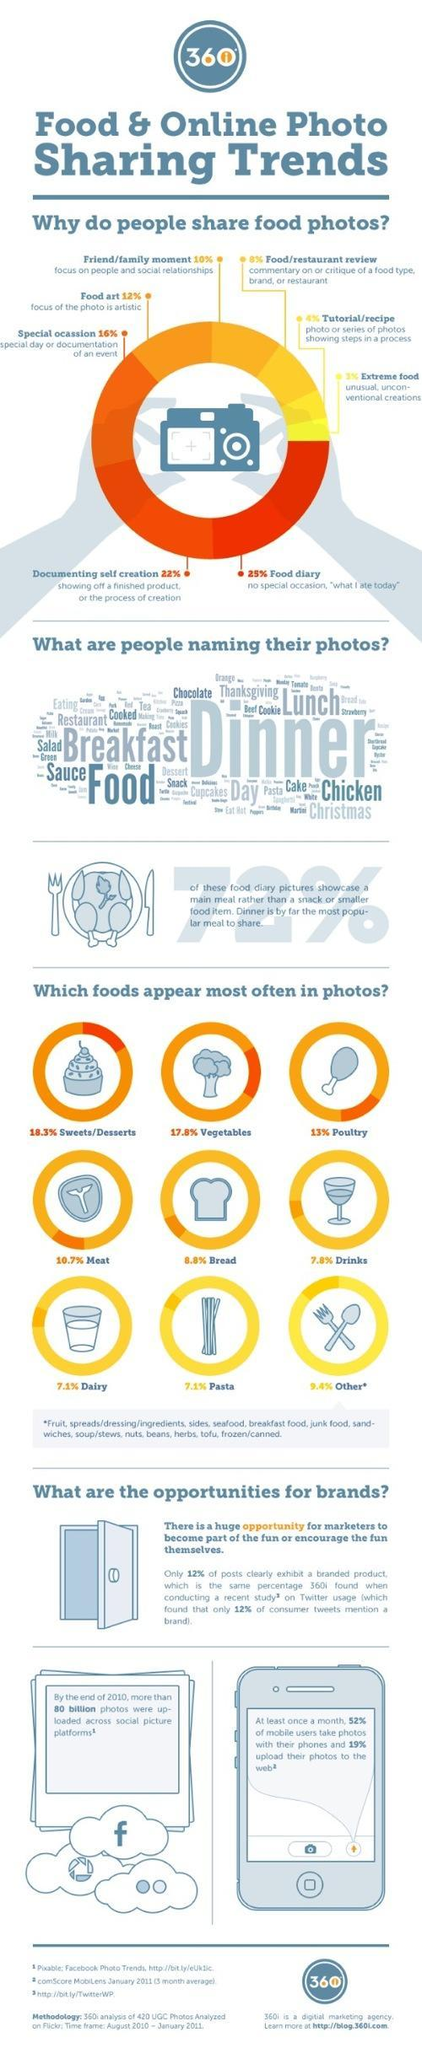Which is the biggest reason for sharing food photos online?
Answer the question with a short phrase. Food diary Which is the most popular name for food photos from the word cloud? Dinner What percent of food diary pictures show a main meal? 72% Which is the third most commonly appearing food in photos? Poultry 